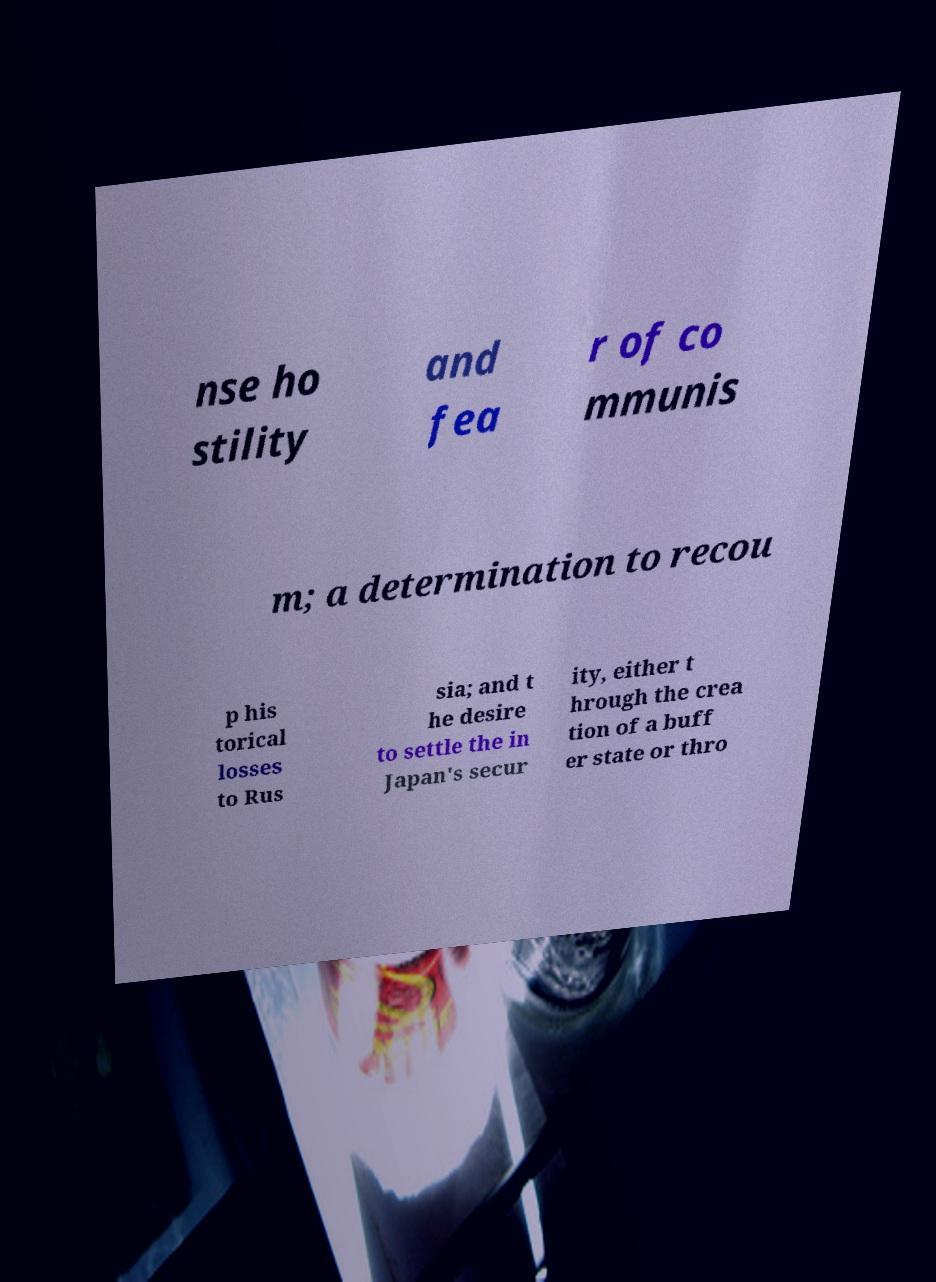There's text embedded in this image that I need extracted. Can you transcribe it verbatim? nse ho stility and fea r of co mmunis m; a determination to recou p his torical losses to Rus sia; and t he desire to settle the in Japan's secur ity, either t hrough the crea tion of a buff er state or thro 